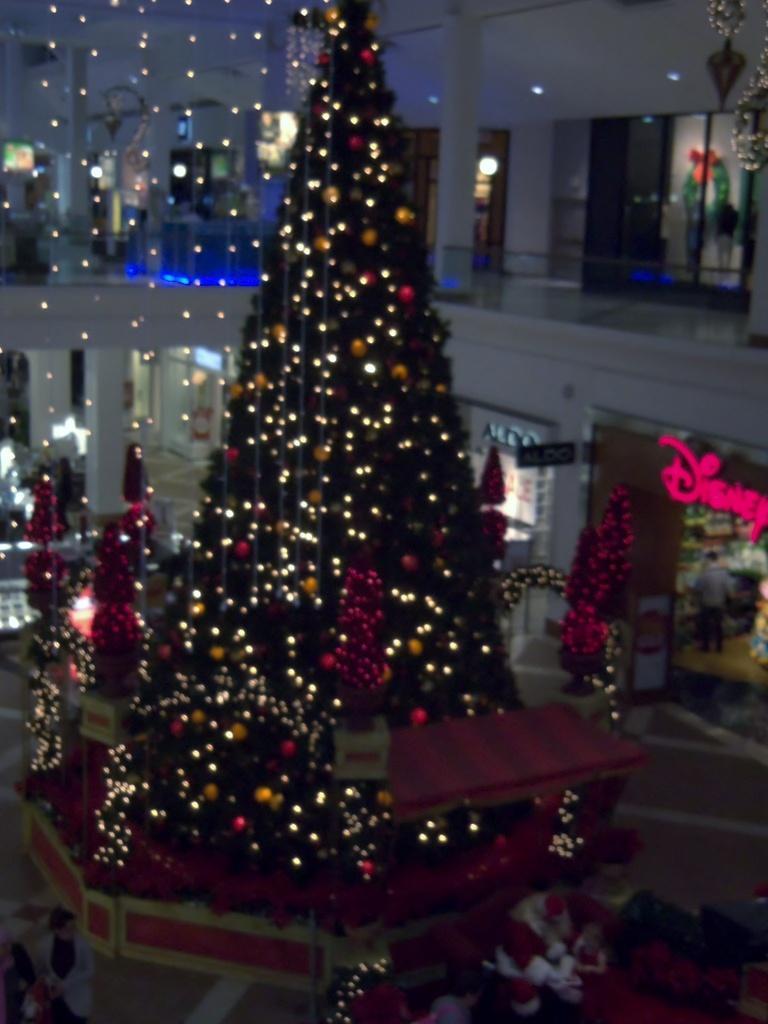How would you summarize this image in a sentence or two? In this picture I can see an inner view of a building and I can see a Christmas tree and few decorative balls and lighting to the tree. 